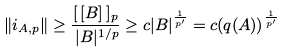<formula> <loc_0><loc_0><loc_500><loc_500>\| i _ { A , p } \| \geq \frac { [ \, [ B ] \, ] _ { p } } { \, | B | ^ { 1 / p } } \geq c | B | ^ { \frac { 1 } { p ^ { \prime } } } = c ( q ( A ) ) ^ { \frac { 1 } { p ^ { \prime } } }</formula> 